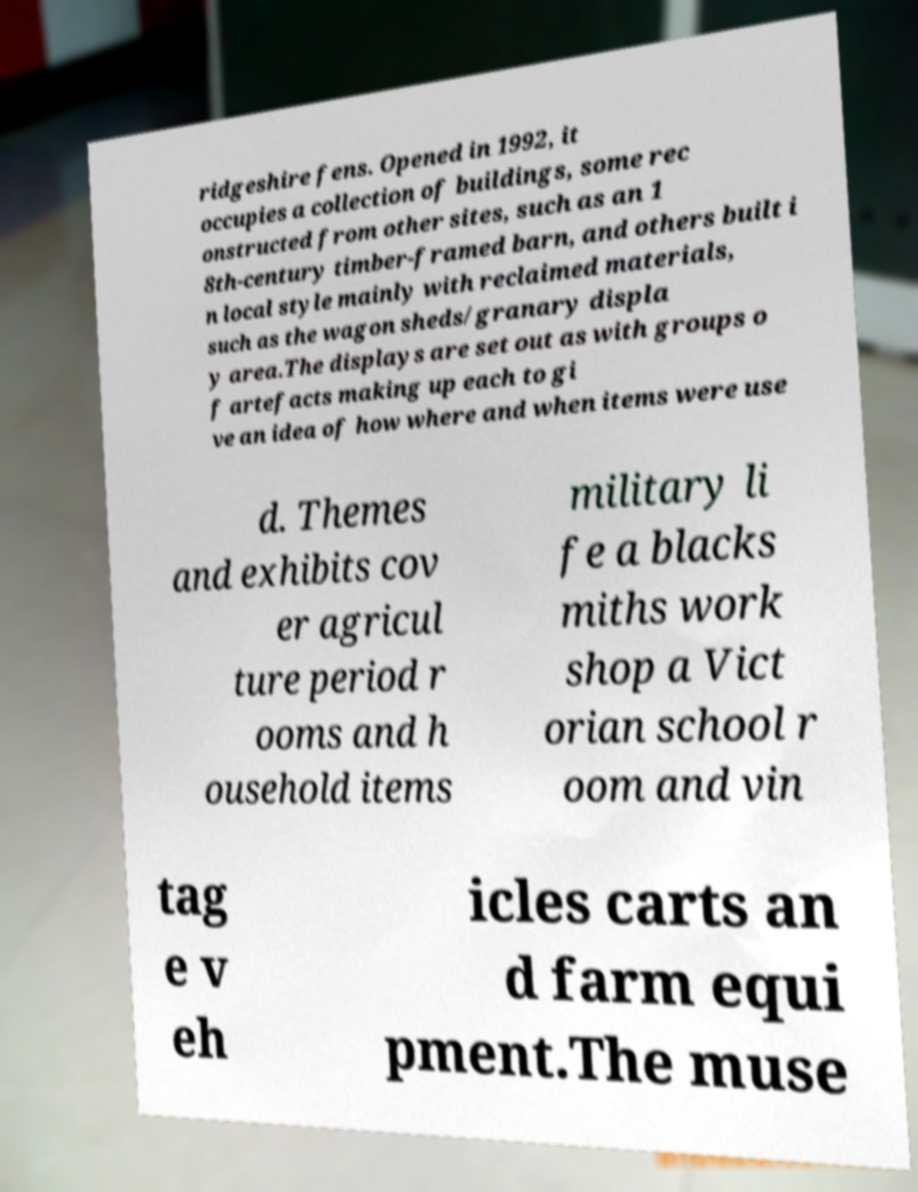Can you read and provide the text displayed in the image?This photo seems to have some interesting text. Can you extract and type it out for me? ridgeshire fens. Opened in 1992, it occupies a collection of buildings, some rec onstructed from other sites, such as an 1 8th-century timber-framed barn, and others built i n local style mainly with reclaimed materials, such as the wagon sheds/granary displa y area.The displays are set out as with groups o f artefacts making up each to gi ve an idea of how where and when items were use d. Themes and exhibits cov er agricul ture period r ooms and h ousehold items military li fe a blacks miths work shop a Vict orian school r oom and vin tag e v eh icles carts an d farm equi pment.The muse 